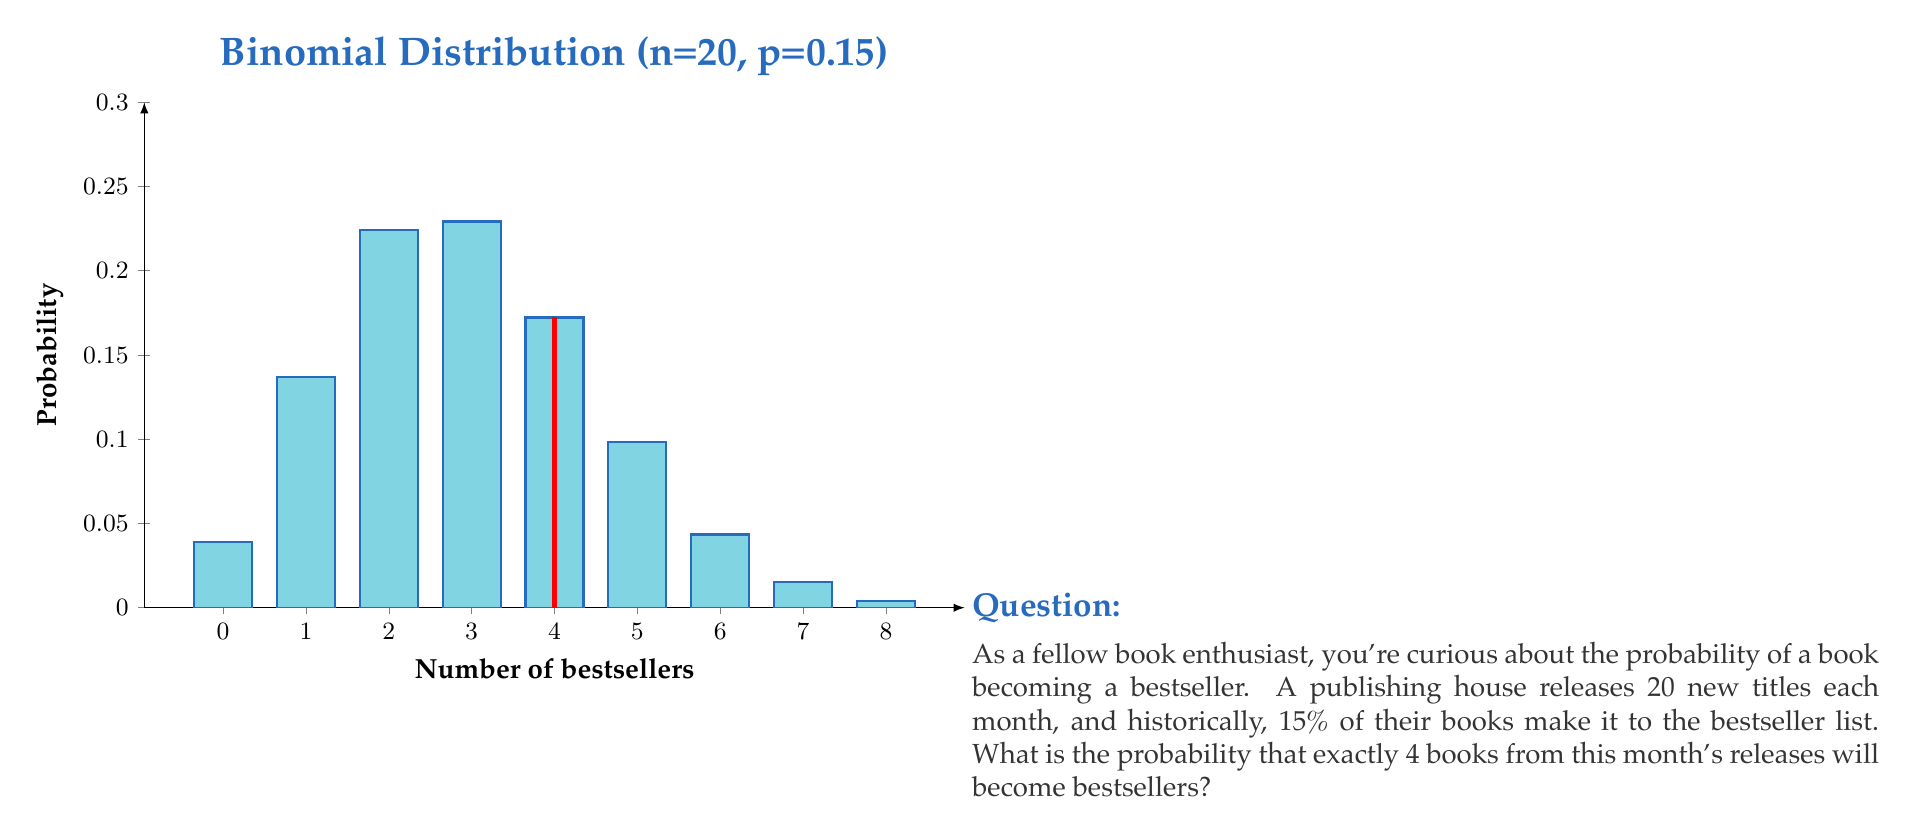Solve this math problem. To solve this problem, we'll use the binomial distribution formula:

$$P(X = k) = \binom{n}{k} p^k (1-p)^{n-k}$$

Where:
- $n$ is the number of trials (20 books)
- $k$ is the number of successes (4 bestsellers)
- $p$ is the probability of success for each trial (15% or 0.15)

Step 1: Calculate the binomial coefficient
$$\binom{20}{4} = \frac{20!}{4!(20-4)!} = 4845$$

Step 2: Calculate $p^k$
$$0.15^4 = 0.0005062$$

Step 3: Calculate $(1-p)^{n-k}$
$$(1-0.15)^{20-4} = 0.85^{16} = 0.0437925$$

Step 4: Multiply all parts together
$$4845 \times 0.0005062 \times 0.0437925 = 0.1074$$

Therefore, the probability of exactly 4 books becoming bestsellers is approximately 0.1074 or 10.74%.
Answer: $0.1074$ or $10.74\%$ 